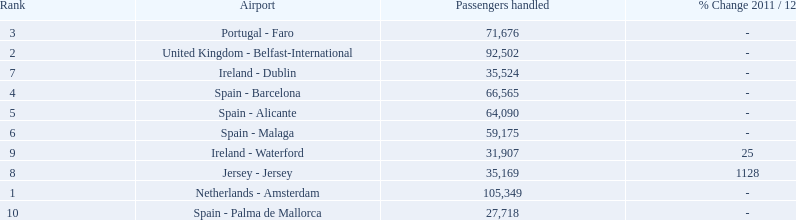Can you parse all the data within this table? {'header': ['Rank', 'Airport', 'Passengers handled', '% Change 2011 / 12'], 'rows': [['3', 'Portugal - Faro', '71,676', '-'], ['2', 'United Kingdom - Belfast-International', '92,502', '-'], ['7', 'Ireland - Dublin', '35,524', '-'], ['4', 'Spain - Barcelona', '66,565', '-'], ['5', 'Spain - Alicante', '64,090', '-'], ['6', 'Spain - Malaga', '59,175', '-'], ['9', 'Ireland - Waterford', '31,907', '25'], ['8', 'Jersey - Jersey', '35,169', '1128'], ['1', 'Netherlands - Amsterdam', '105,349', '-'], ['10', 'Spain - Palma de Mallorca', '27,718', '-']]} What are the numbers of passengers handled along the different routes in the airport? 105,349, 92,502, 71,676, 66,565, 64,090, 59,175, 35,524, 35,169, 31,907, 27,718. Of these routes, which handles less than 30,000 passengers? Spain - Palma de Mallorca. 